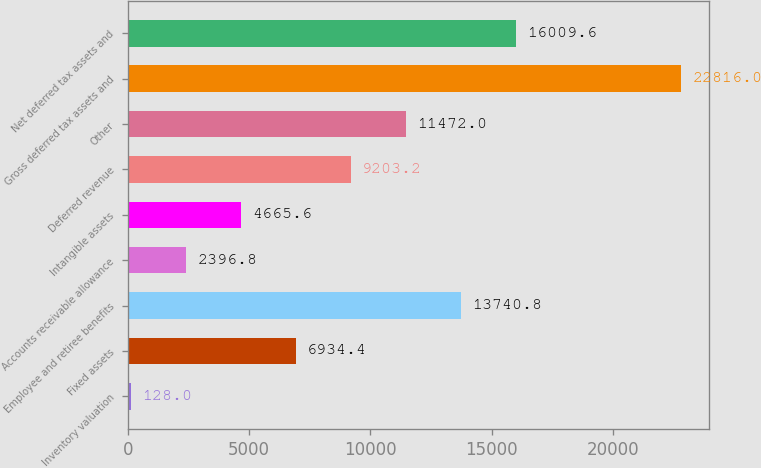Convert chart to OTSL. <chart><loc_0><loc_0><loc_500><loc_500><bar_chart><fcel>Inventory valuation<fcel>Fixed assets<fcel>Employee and retiree benefits<fcel>Accounts receivable allowance<fcel>Intangible assets<fcel>Deferred revenue<fcel>Other<fcel>Gross deferred tax assets and<fcel>Net deferred tax assets and<nl><fcel>128<fcel>6934.4<fcel>13740.8<fcel>2396.8<fcel>4665.6<fcel>9203.2<fcel>11472<fcel>22816<fcel>16009.6<nl></chart> 